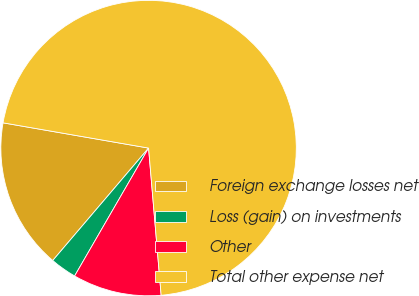Convert chart to OTSL. <chart><loc_0><loc_0><loc_500><loc_500><pie_chart><fcel>Foreign exchange losses net<fcel>Loss (gain) on investments<fcel>Other<fcel>Total other expense net<nl><fcel>16.5%<fcel>2.89%<fcel>9.7%<fcel>70.91%<nl></chart> 